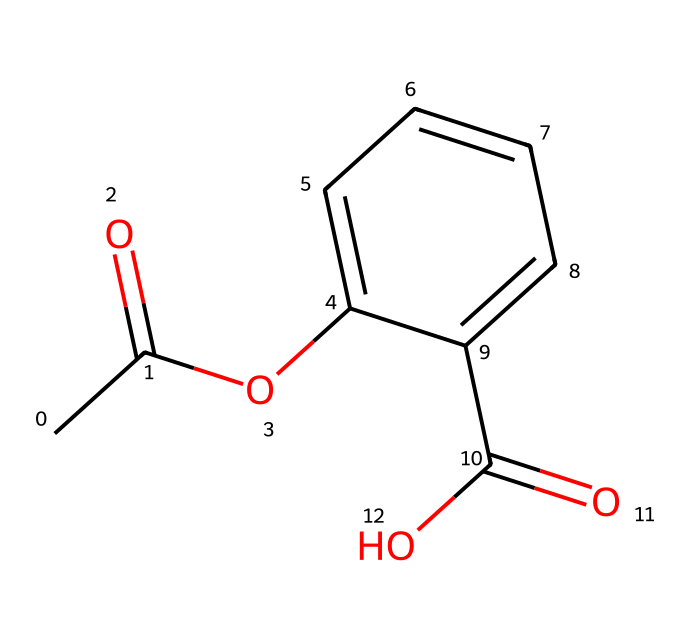What is the molecular formula of the chemical represented by the SMILES? To determine the molecular formula, we interpret the SMILES notation. The structure includes 8 carbon (C) atoms, 8 hydrogen (H) atoms, and 4 oxygen (O) atoms. Thus, the molecular formula is C8H8O4.
Answer: C8H8O4 How many rings are present in this chemical structure? By analyzing the SMILES, we identify one ring indicated by 'c' which denotes the aromatic carbon atoms. Thus, there is one ring present in the structure.
Answer: 1 What functional groups are represented in this chemical? The chemical contains carboxylic acid (-COOH) and ester (-O-C(=O)-) functional groups. We can see the carboxylic acid at the end of the molecule and the ester linkage is part of the beginning structure.
Answer: carboxylic acid and ester What type of substance is this compound? Given the presence of an ester and a carboxylic acid, along with its structure, this compound is classified as a drug used perhaps as a preservative. Typically, substances with these functional groups act as preservatives.
Answer: drug What is the significance of the ester group in this chemical? The ester group (-O-C(=O)-) is significant as it can impart stability and improve solubility in various media. This property is often exploited in the formulation of preservatives in historical landmark maintenance, enhancing their effectiveness.
Answer: stability and solubility Does this chemical have any chirality? The chemical has no stereogenic centers (as there are no carbon atoms bonded to four different groups), therefore it is not chiral.
Answer: no 